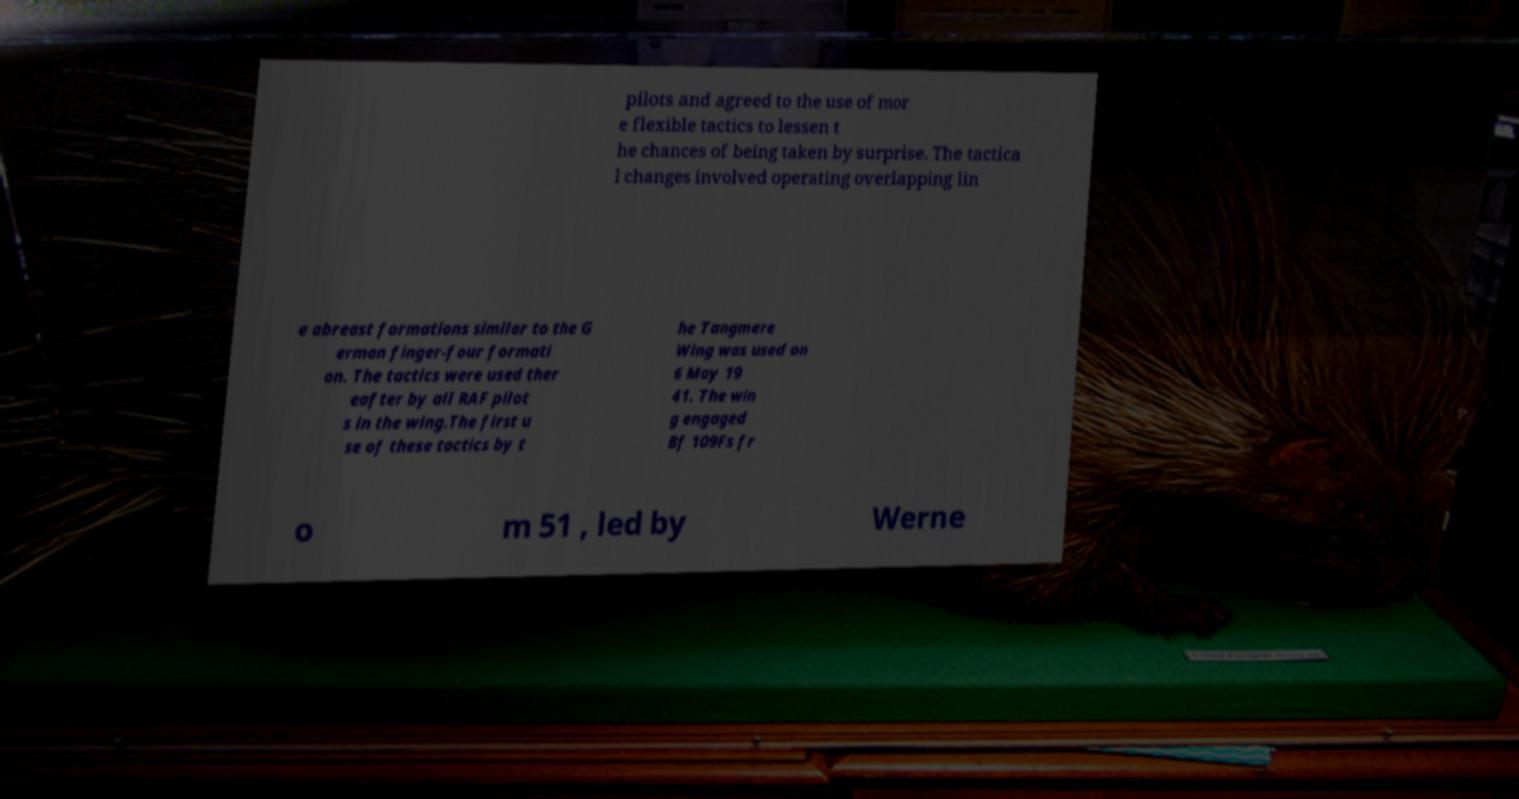What messages or text are displayed in this image? I need them in a readable, typed format. pilots and agreed to the use of mor e flexible tactics to lessen t he chances of being taken by surprise. The tactica l changes involved operating overlapping lin e abreast formations similar to the G erman finger-four formati on. The tactics were used ther eafter by all RAF pilot s in the wing.The first u se of these tactics by t he Tangmere Wing was used on 6 May 19 41. The win g engaged Bf 109Fs fr o m 51 , led by Werne 